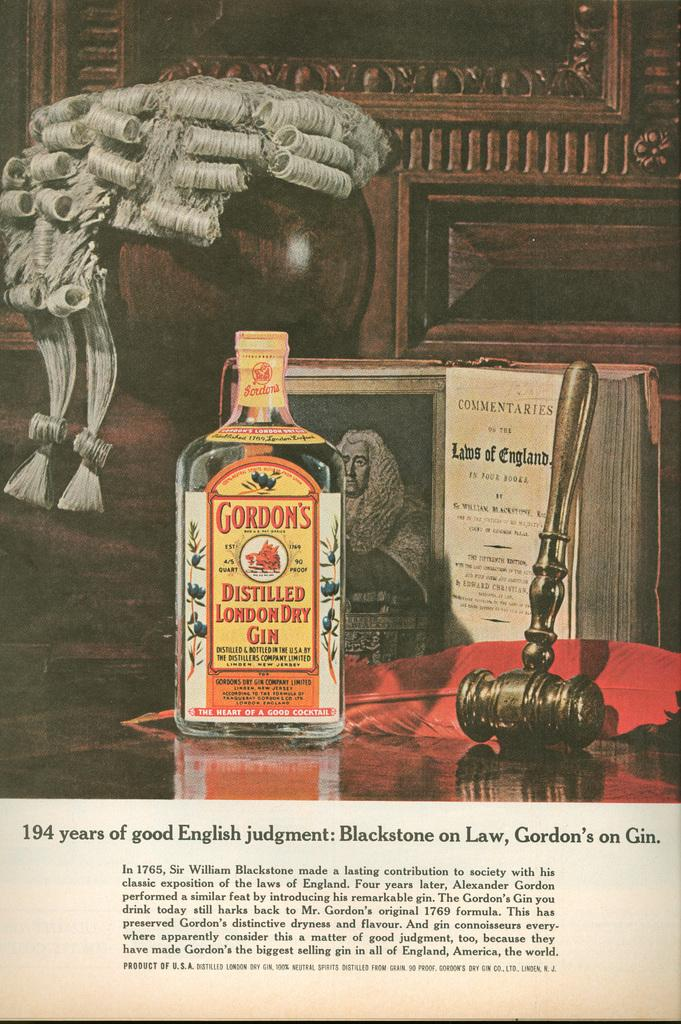<image>
Give a short and clear explanation of the subsequent image. A bottle of Gordon's gin in front of a book and a small hammer 